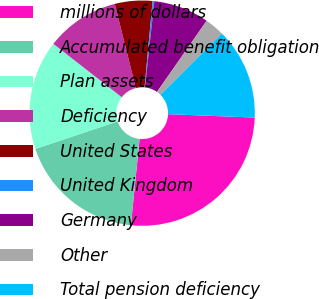Convert chart. <chart><loc_0><loc_0><loc_500><loc_500><pie_chart><fcel>millions of dollars<fcel>Accumulated benefit obligation<fcel>Plan assets<fcel>Deficiency<fcel>United States<fcel>United Kingdom<fcel>Germany<fcel>Other<fcel>Total pension deficiency<nl><fcel>25.98%<fcel>18.26%<fcel>15.69%<fcel>10.54%<fcel>5.39%<fcel>0.25%<fcel>7.97%<fcel>2.82%<fcel>13.11%<nl></chart> 